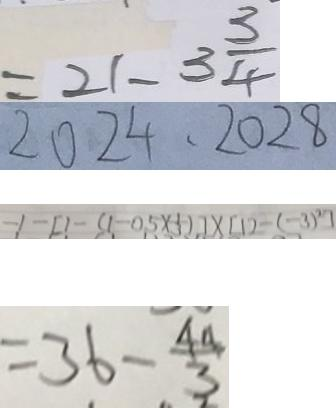<formula> <loc_0><loc_0><loc_500><loc_500>= 2 1 - 3 \frac { 3 } { 4 } 
 2 0 2 4 , 2 0 2 8 
 - 1 - [ 1 - ( 1 - 0 . 5 \times \frac { 1 } { 3 } ] \times [ 1 2 - ( - 3 ) ^ { 2 } ] 
 = 3 6 - \frac { 4 4 } { 3 }</formula> 